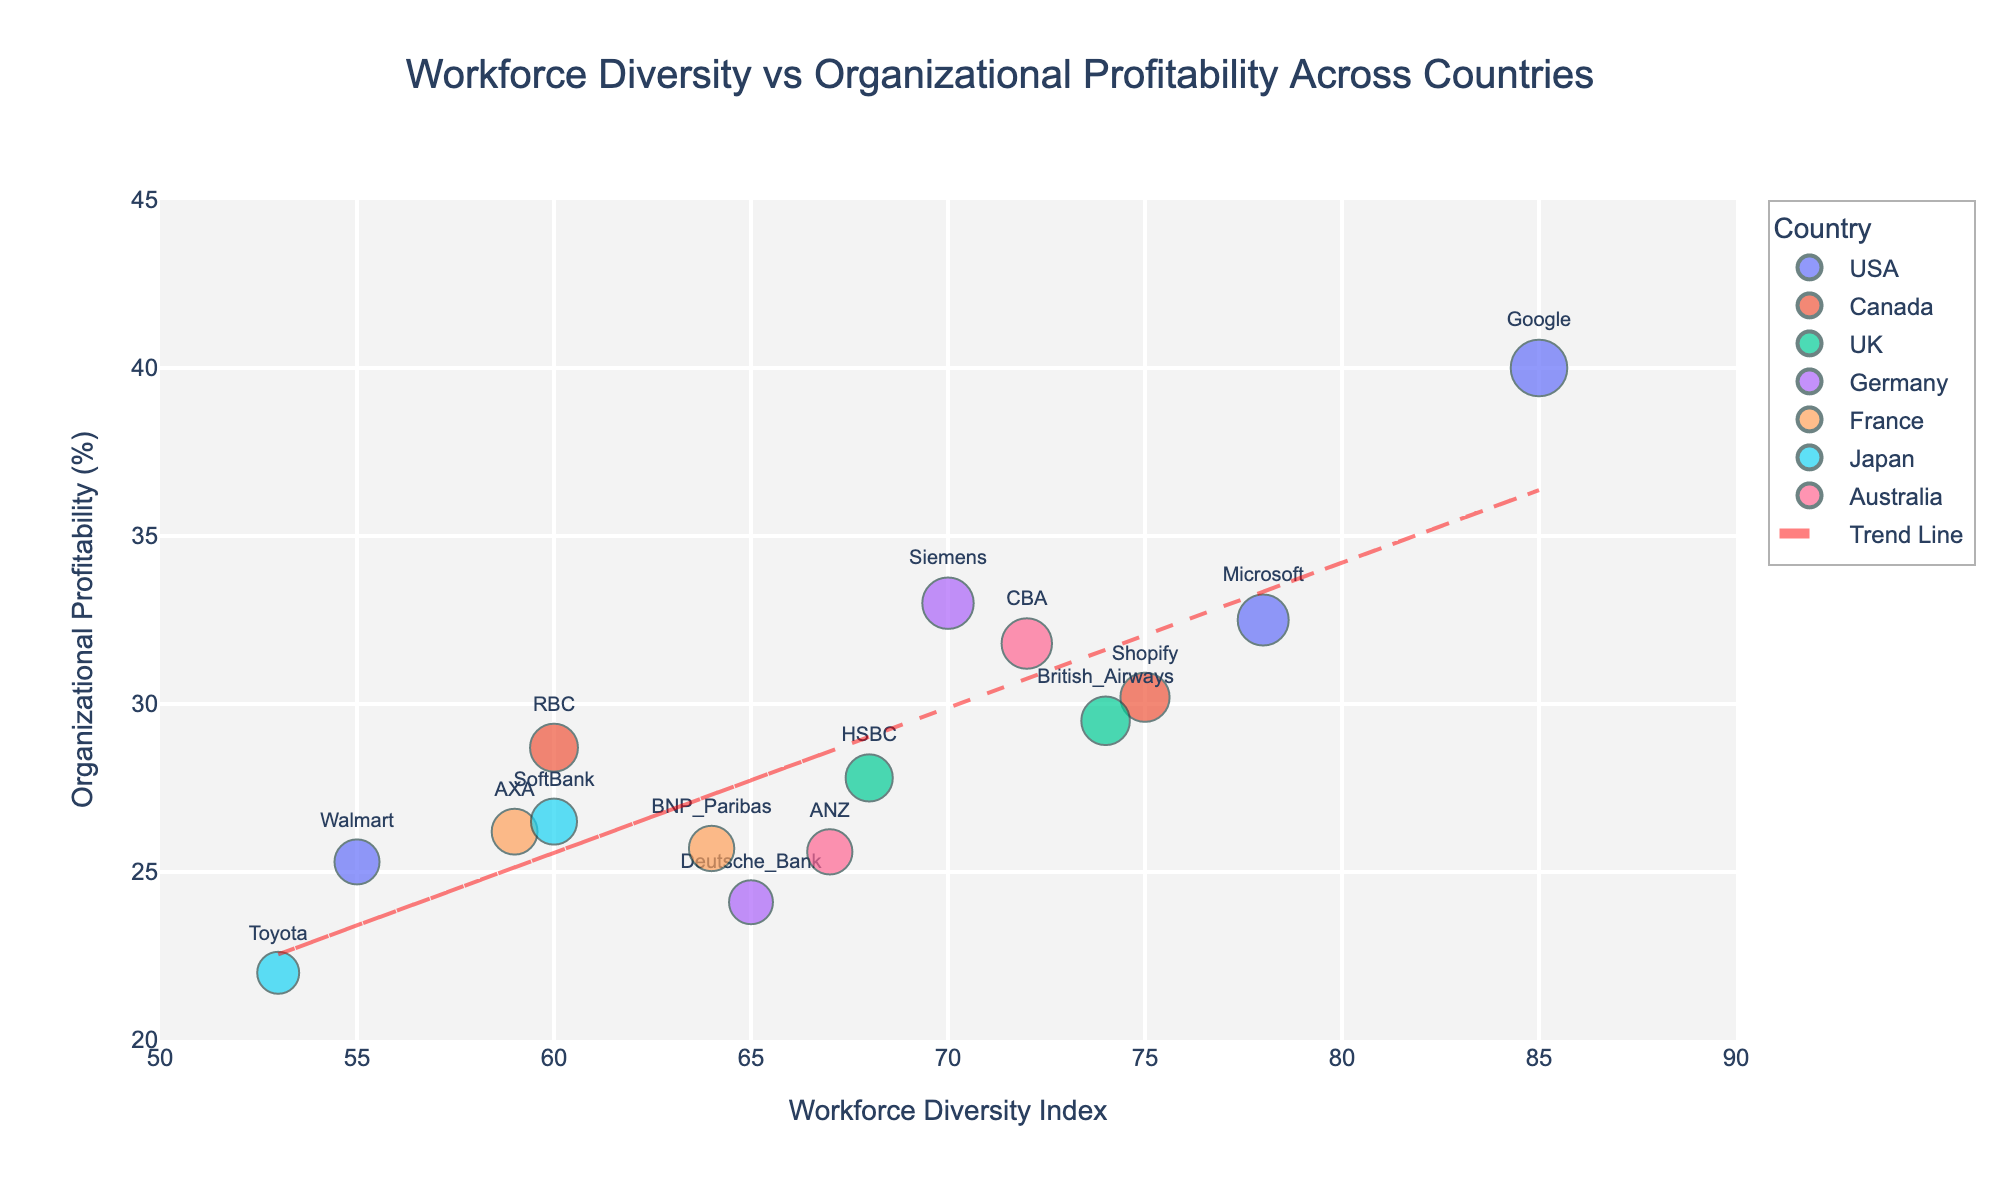What is the title of the plot? The title is located at the top center of the plot. It provides a summary of the plot's overall subject. The title here states "Workforce Diversity vs Organizational Profitability Across Countries" which indicates the relationship being visualized.
Answer: Workforce Diversity vs Organizational Profitability Across Countries Which country has the company with the highest Diversity Index? To find the highest Diversity Index, look at the x-axis for the data point furthest to the right. The company with the highest Diversity Index is Google with a value of 85, and it is from the USA.
Answer: USA What is the range of values on the y-axis? The y-axis represents Organizational Profitability. The range of values can be seen from the lowest point to the highest point on the y-axis. The labeled values range from 20 to 45 percent.
Answer: 20 to 45 Which company has the highest Organizational Profitability and what is its value? Look for the highest data point on the y-axis and check the label. Google is the company with the highest Organizational Profitability at 40.0%.
Answer: Google, 40.0% How many companies are from Canada? Check the legend for the color representing Canada and count the data points of that color in the scatter plot. There are two companies from Canada, Shopify and RBC.
Answer: 2 What is the average Diversity Index of companies from the UK? Identify the companies from the UK (HSBC and British Airways), find their Diversity Index values (68 and 74), sum them up and divide by the number of companies. (68 + 74) / 2 = 71.
Answer: 71 Which country has the widest spread of Organizational Profitability values? Observe the vertical spread of data points for each country by their colors. The USA shows the widest spread in Organizational Profitability values from 25.3% to 40.0%.
Answer: USA Which company is closest to the trend line and what are its Diversity Index and Profitability values? Compare the data points to the red dashed trend line. The company closest to the trend line is ANA with a Diversity Index of 67 and a Profitability of 25.6%. This can be determined by visually checking for the smallest vertical distance to the trend line.
Answer: ANZ, 67, 25.6% Do companies with a higher Diversity Index generally show higher or lower Profitability according to the trend line? The slope of the trend line indicates the general direction of the relationship. With a positive slope, the trend line shows that higher Diversity Index values are generally associated with higher Profitability.
Answer: Higher 